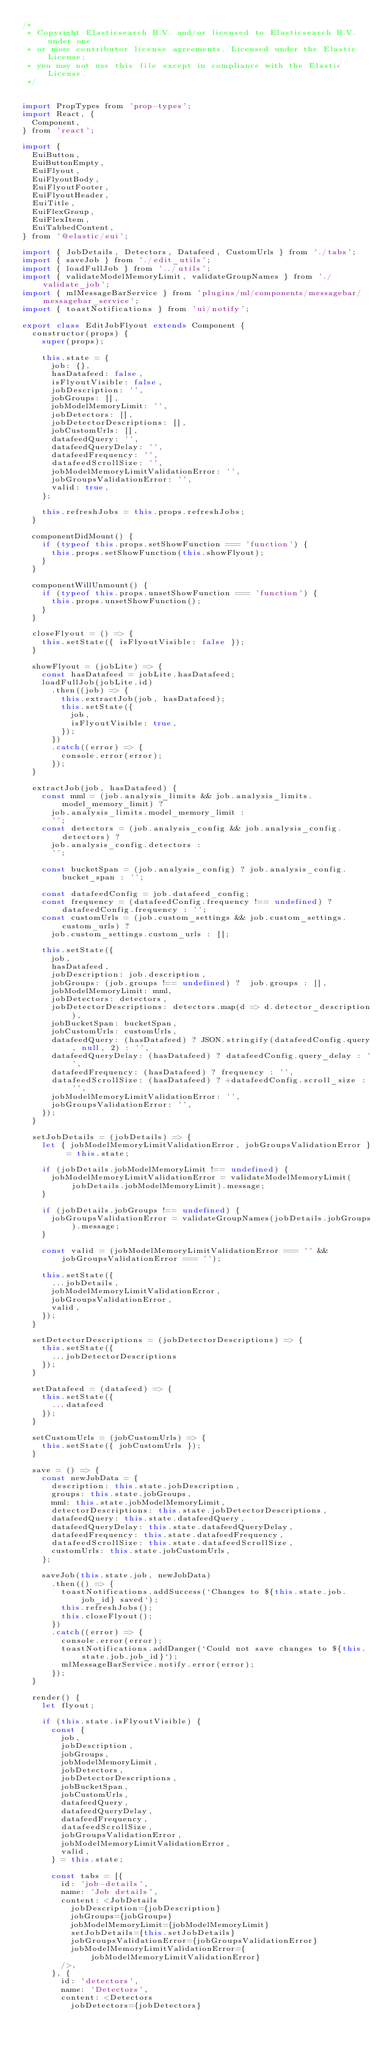Convert code to text. <code><loc_0><loc_0><loc_500><loc_500><_JavaScript_>/*
 * Copyright Elasticsearch B.V. and/or licensed to Elasticsearch B.V. under one
 * or more contributor license agreements. Licensed under the Elastic License;
 * you may not use this file except in compliance with the Elastic License.
 */


import PropTypes from 'prop-types';
import React, {
  Component,
} from 'react';

import {
  EuiButton,
  EuiButtonEmpty,
  EuiFlyout,
  EuiFlyoutBody,
  EuiFlyoutFooter,
  EuiFlyoutHeader,
  EuiTitle,
  EuiFlexGroup,
  EuiFlexItem,
  EuiTabbedContent,
} from '@elastic/eui';

import { JobDetails, Detectors, Datafeed, CustomUrls } from './tabs';
import { saveJob } from './edit_utils';
import { loadFullJob } from '../utils';
import { validateModelMemoryLimit, validateGroupNames } from './validate_job';
import { mlMessageBarService } from 'plugins/ml/components/messagebar/messagebar_service';
import { toastNotifications } from 'ui/notify';

export class EditJobFlyout extends Component {
  constructor(props) {
    super(props);

    this.state = {
      job: {},
      hasDatafeed: false,
      isFlyoutVisible: false,
      jobDescription: '',
      jobGroups: [],
      jobModelMemoryLimit: '',
      jobDetectors: [],
      jobDetectorDescriptions: [],
      jobCustomUrls: [],
      datafeedQuery: '',
      datafeedQueryDelay: '',
      datafeedFrequency: '',
      datafeedScrollSize: '',
      jobModelMemoryLimitValidationError: '',
      jobGroupsValidationError: '',
      valid: true,
    };

    this.refreshJobs = this.props.refreshJobs;
  }

  componentDidMount() {
    if (typeof this.props.setShowFunction === 'function') {
      this.props.setShowFunction(this.showFlyout);
    }
  }

  componentWillUnmount() {
    if (typeof this.props.unsetShowFunction === 'function') {
      this.props.unsetShowFunction();
    }
  }

  closeFlyout = () => {
    this.setState({ isFlyoutVisible: false });
  }

  showFlyout = (jobLite) => {
    const hasDatafeed = jobLite.hasDatafeed;
    loadFullJob(jobLite.id)
    	.then((job) => {
        this.extractJob(job, hasDatafeed);
        this.setState({
          job,
          isFlyoutVisible: true,
        });
      })
      .catch((error) => {
        console.error(error);
      });
  }

  extractJob(job, hasDatafeed) {
    const mml = (job.analysis_limits && job.analysis_limits.model_memory_limit) ?
      job.analysis_limits.model_memory_limit :
      '';
    const detectors = (job.analysis_config && job.analysis_config.detectors) ?
      job.analysis_config.detectors :
      '';

    const bucketSpan = (job.analysis_config) ? job.analysis_config.bucket_span : '';

    const datafeedConfig = job.datafeed_config;
    const frequency = (datafeedConfig.frequency !== undefined) ? datafeedConfig.frequency : '';
    const customUrls = (job.custom_settings && job.custom_settings.custom_urls) ?
      job.custom_settings.custom_urls : [];

    this.setState({
      job,
      hasDatafeed,
      jobDescription: job.description,
      jobGroups: (job.groups !== undefined) ?  job.groups : [],
      jobModelMemoryLimit: mml,
      jobDetectors: detectors,
      jobDetectorDescriptions: detectors.map(d => d.detector_description),
      jobBucketSpan: bucketSpan,
      jobCustomUrls: customUrls,
      datafeedQuery: (hasDatafeed) ? JSON.stringify(datafeedConfig.query, null, 2) : '',
      datafeedQueryDelay: (hasDatafeed) ? datafeedConfig.query_delay : '',
      datafeedFrequency: (hasDatafeed) ? frequency : '',
      datafeedScrollSize: (hasDatafeed) ? +datafeedConfig.scroll_size : '',
      jobModelMemoryLimitValidationError: '',
      jobGroupsValidationError: '',
    });
  }

  setJobDetails = (jobDetails) => {
    let { jobModelMemoryLimitValidationError, jobGroupsValidationError } = this.state;

    if (jobDetails.jobModelMemoryLimit !== undefined) {
      jobModelMemoryLimitValidationError = validateModelMemoryLimit(jobDetails.jobModelMemoryLimit).message;
    }

    if (jobDetails.jobGroups !== undefined) {
      jobGroupsValidationError = validateGroupNames(jobDetails.jobGroups).message;
    }

    const valid = (jobModelMemoryLimitValidationError === '' && jobGroupsValidationError === '');

    this.setState({
      ...jobDetails,
      jobModelMemoryLimitValidationError,
      jobGroupsValidationError,
      valid,
    });
  }

  setDetectorDescriptions = (jobDetectorDescriptions) => {
    this.setState({
      ...jobDetectorDescriptions
    });
  }

  setDatafeed = (datafeed) => {
    this.setState({
      ...datafeed
    });
  }

  setCustomUrls = (jobCustomUrls) => {
    this.setState({ jobCustomUrls });
  }

  save = () => {
    const newJobData = {
      description: this.state.jobDescription,
      groups: this.state.jobGroups,
      mml: this.state.jobModelMemoryLimit,
      detectorDescriptions: this.state.jobDetectorDescriptions,
      datafeedQuery: this.state.datafeedQuery,
      datafeedQueryDelay: this.state.datafeedQueryDelay,
      datafeedFrequency: this.state.datafeedFrequency,
      datafeedScrollSize: this.state.datafeedScrollSize,
      customUrls: this.state.jobCustomUrls,
    };

    saveJob(this.state.job, newJobData)
      .then(() => {
        toastNotifications.addSuccess(`Changes to ${this.state.job.job_id} saved`);
        this.refreshJobs();
        this.closeFlyout();
      })
      .catch((error) => {
        console.error(error);
        toastNotifications.addDanger(`Could not save changes to ${this.state.job.job_id}`);
        mlMessageBarService.notify.error(error);
      });
  }

  render() {
    let flyout;

    if (this.state.isFlyoutVisible) {
      const {
        job,
        jobDescription,
        jobGroups,
        jobModelMemoryLimit,
        jobDetectors,
        jobDetectorDescriptions,
        jobBucketSpan,
        jobCustomUrls,
        datafeedQuery,
        datafeedQueryDelay,
        datafeedFrequency,
        datafeedScrollSize,
        jobGroupsValidationError,
        jobModelMemoryLimitValidationError,
        valid,
      } = this.state;

      const tabs = [{
        id: 'job-details',
        name: 'Job details',
        content: <JobDetails
          jobDescription={jobDescription}
          jobGroups={jobGroups}
          jobModelMemoryLimit={jobModelMemoryLimit}
          setJobDetails={this.setJobDetails}
          jobGroupsValidationError={jobGroupsValidationError}
          jobModelMemoryLimitValidationError={jobModelMemoryLimitValidationError}
        />,
      }, {
        id: 'detectors',
        name: 'Detectors',
        content: <Detectors
          jobDetectors={jobDetectors}</code> 